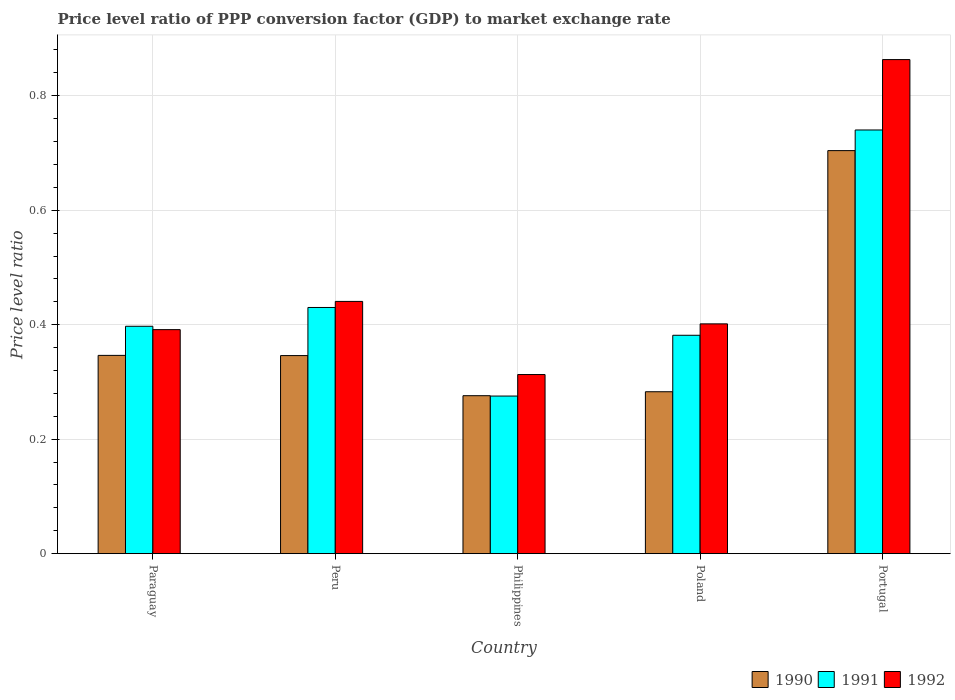How many different coloured bars are there?
Ensure brevity in your answer.  3. How many groups of bars are there?
Provide a succinct answer. 5. How many bars are there on the 2nd tick from the right?
Your response must be concise. 3. What is the label of the 1st group of bars from the left?
Ensure brevity in your answer.  Paraguay. What is the price level ratio in 1990 in Poland?
Your answer should be very brief. 0.28. Across all countries, what is the maximum price level ratio in 1992?
Provide a succinct answer. 0.86. Across all countries, what is the minimum price level ratio in 1991?
Provide a short and direct response. 0.28. In which country was the price level ratio in 1991 minimum?
Offer a very short reply. Philippines. What is the total price level ratio in 1992 in the graph?
Offer a very short reply. 2.41. What is the difference between the price level ratio in 1992 in Paraguay and that in Peru?
Your answer should be very brief. -0.05. What is the difference between the price level ratio in 1992 in Peru and the price level ratio in 1991 in Poland?
Ensure brevity in your answer.  0.06. What is the average price level ratio in 1990 per country?
Give a very brief answer. 0.39. What is the difference between the price level ratio of/in 1992 and price level ratio of/in 1990 in Peru?
Provide a short and direct response. 0.09. In how many countries, is the price level ratio in 1992 greater than 0.6000000000000001?
Ensure brevity in your answer.  1. What is the ratio of the price level ratio in 1992 in Peru to that in Philippines?
Provide a succinct answer. 1.41. Is the difference between the price level ratio in 1992 in Paraguay and Peru greater than the difference between the price level ratio in 1990 in Paraguay and Peru?
Your answer should be very brief. No. What is the difference between the highest and the second highest price level ratio in 1990?
Give a very brief answer. 0.36. What is the difference between the highest and the lowest price level ratio in 1990?
Your answer should be compact. 0.43. In how many countries, is the price level ratio in 1992 greater than the average price level ratio in 1992 taken over all countries?
Provide a short and direct response. 1. What does the 1st bar from the left in Paraguay represents?
Your answer should be compact. 1990. What does the 2nd bar from the right in Portugal represents?
Your response must be concise. 1991. Is it the case that in every country, the sum of the price level ratio in 1991 and price level ratio in 1992 is greater than the price level ratio in 1990?
Your answer should be compact. Yes. Are the values on the major ticks of Y-axis written in scientific E-notation?
Offer a very short reply. No. What is the title of the graph?
Keep it short and to the point. Price level ratio of PPP conversion factor (GDP) to market exchange rate. Does "1965" appear as one of the legend labels in the graph?
Keep it short and to the point. No. What is the label or title of the X-axis?
Your response must be concise. Country. What is the label or title of the Y-axis?
Give a very brief answer. Price level ratio. What is the Price level ratio of 1990 in Paraguay?
Offer a terse response. 0.35. What is the Price level ratio in 1991 in Paraguay?
Your answer should be compact. 0.4. What is the Price level ratio in 1992 in Paraguay?
Give a very brief answer. 0.39. What is the Price level ratio in 1990 in Peru?
Offer a terse response. 0.35. What is the Price level ratio of 1991 in Peru?
Keep it short and to the point. 0.43. What is the Price level ratio in 1992 in Peru?
Offer a terse response. 0.44. What is the Price level ratio of 1990 in Philippines?
Give a very brief answer. 0.28. What is the Price level ratio of 1991 in Philippines?
Your response must be concise. 0.28. What is the Price level ratio of 1992 in Philippines?
Offer a very short reply. 0.31. What is the Price level ratio of 1990 in Poland?
Ensure brevity in your answer.  0.28. What is the Price level ratio in 1991 in Poland?
Ensure brevity in your answer.  0.38. What is the Price level ratio of 1992 in Poland?
Your response must be concise. 0.4. What is the Price level ratio in 1990 in Portugal?
Your answer should be very brief. 0.7. What is the Price level ratio of 1991 in Portugal?
Provide a succinct answer. 0.74. What is the Price level ratio in 1992 in Portugal?
Provide a succinct answer. 0.86. Across all countries, what is the maximum Price level ratio in 1990?
Your response must be concise. 0.7. Across all countries, what is the maximum Price level ratio of 1991?
Ensure brevity in your answer.  0.74. Across all countries, what is the maximum Price level ratio in 1992?
Offer a terse response. 0.86. Across all countries, what is the minimum Price level ratio in 1990?
Make the answer very short. 0.28. Across all countries, what is the minimum Price level ratio of 1991?
Keep it short and to the point. 0.28. Across all countries, what is the minimum Price level ratio in 1992?
Provide a succinct answer. 0.31. What is the total Price level ratio in 1990 in the graph?
Give a very brief answer. 1.96. What is the total Price level ratio of 1991 in the graph?
Keep it short and to the point. 2.22. What is the total Price level ratio in 1992 in the graph?
Provide a succinct answer. 2.41. What is the difference between the Price level ratio in 1990 in Paraguay and that in Peru?
Provide a short and direct response. 0. What is the difference between the Price level ratio of 1991 in Paraguay and that in Peru?
Provide a short and direct response. -0.03. What is the difference between the Price level ratio in 1992 in Paraguay and that in Peru?
Your answer should be compact. -0.05. What is the difference between the Price level ratio in 1990 in Paraguay and that in Philippines?
Your answer should be very brief. 0.07. What is the difference between the Price level ratio of 1991 in Paraguay and that in Philippines?
Offer a very short reply. 0.12. What is the difference between the Price level ratio of 1992 in Paraguay and that in Philippines?
Give a very brief answer. 0.08. What is the difference between the Price level ratio in 1990 in Paraguay and that in Poland?
Provide a short and direct response. 0.06. What is the difference between the Price level ratio of 1991 in Paraguay and that in Poland?
Offer a very short reply. 0.02. What is the difference between the Price level ratio of 1992 in Paraguay and that in Poland?
Your answer should be very brief. -0.01. What is the difference between the Price level ratio in 1990 in Paraguay and that in Portugal?
Ensure brevity in your answer.  -0.36. What is the difference between the Price level ratio of 1991 in Paraguay and that in Portugal?
Keep it short and to the point. -0.34. What is the difference between the Price level ratio of 1992 in Paraguay and that in Portugal?
Provide a succinct answer. -0.47. What is the difference between the Price level ratio in 1990 in Peru and that in Philippines?
Provide a short and direct response. 0.07. What is the difference between the Price level ratio in 1991 in Peru and that in Philippines?
Ensure brevity in your answer.  0.15. What is the difference between the Price level ratio in 1992 in Peru and that in Philippines?
Ensure brevity in your answer.  0.13. What is the difference between the Price level ratio of 1990 in Peru and that in Poland?
Your response must be concise. 0.06. What is the difference between the Price level ratio in 1991 in Peru and that in Poland?
Keep it short and to the point. 0.05. What is the difference between the Price level ratio of 1992 in Peru and that in Poland?
Give a very brief answer. 0.04. What is the difference between the Price level ratio of 1990 in Peru and that in Portugal?
Ensure brevity in your answer.  -0.36. What is the difference between the Price level ratio in 1991 in Peru and that in Portugal?
Keep it short and to the point. -0.31. What is the difference between the Price level ratio in 1992 in Peru and that in Portugal?
Your answer should be very brief. -0.42. What is the difference between the Price level ratio in 1990 in Philippines and that in Poland?
Provide a short and direct response. -0.01. What is the difference between the Price level ratio of 1991 in Philippines and that in Poland?
Provide a short and direct response. -0.11. What is the difference between the Price level ratio in 1992 in Philippines and that in Poland?
Ensure brevity in your answer.  -0.09. What is the difference between the Price level ratio of 1990 in Philippines and that in Portugal?
Keep it short and to the point. -0.43. What is the difference between the Price level ratio in 1991 in Philippines and that in Portugal?
Provide a succinct answer. -0.46. What is the difference between the Price level ratio of 1992 in Philippines and that in Portugal?
Provide a succinct answer. -0.55. What is the difference between the Price level ratio in 1990 in Poland and that in Portugal?
Your answer should be very brief. -0.42. What is the difference between the Price level ratio in 1991 in Poland and that in Portugal?
Offer a terse response. -0.36. What is the difference between the Price level ratio of 1992 in Poland and that in Portugal?
Your answer should be very brief. -0.46. What is the difference between the Price level ratio in 1990 in Paraguay and the Price level ratio in 1991 in Peru?
Provide a succinct answer. -0.08. What is the difference between the Price level ratio in 1990 in Paraguay and the Price level ratio in 1992 in Peru?
Give a very brief answer. -0.09. What is the difference between the Price level ratio of 1991 in Paraguay and the Price level ratio of 1992 in Peru?
Make the answer very short. -0.04. What is the difference between the Price level ratio in 1990 in Paraguay and the Price level ratio in 1991 in Philippines?
Provide a succinct answer. 0.07. What is the difference between the Price level ratio in 1990 in Paraguay and the Price level ratio in 1992 in Philippines?
Give a very brief answer. 0.03. What is the difference between the Price level ratio of 1991 in Paraguay and the Price level ratio of 1992 in Philippines?
Offer a terse response. 0.08. What is the difference between the Price level ratio of 1990 in Paraguay and the Price level ratio of 1991 in Poland?
Keep it short and to the point. -0.04. What is the difference between the Price level ratio of 1990 in Paraguay and the Price level ratio of 1992 in Poland?
Give a very brief answer. -0.06. What is the difference between the Price level ratio of 1991 in Paraguay and the Price level ratio of 1992 in Poland?
Provide a succinct answer. -0. What is the difference between the Price level ratio in 1990 in Paraguay and the Price level ratio in 1991 in Portugal?
Your answer should be compact. -0.39. What is the difference between the Price level ratio of 1990 in Paraguay and the Price level ratio of 1992 in Portugal?
Ensure brevity in your answer.  -0.52. What is the difference between the Price level ratio of 1991 in Paraguay and the Price level ratio of 1992 in Portugal?
Your response must be concise. -0.47. What is the difference between the Price level ratio in 1990 in Peru and the Price level ratio in 1991 in Philippines?
Offer a very short reply. 0.07. What is the difference between the Price level ratio of 1990 in Peru and the Price level ratio of 1992 in Philippines?
Offer a very short reply. 0.03. What is the difference between the Price level ratio in 1991 in Peru and the Price level ratio in 1992 in Philippines?
Give a very brief answer. 0.12. What is the difference between the Price level ratio in 1990 in Peru and the Price level ratio in 1991 in Poland?
Your response must be concise. -0.04. What is the difference between the Price level ratio in 1990 in Peru and the Price level ratio in 1992 in Poland?
Provide a succinct answer. -0.06. What is the difference between the Price level ratio of 1991 in Peru and the Price level ratio of 1992 in Poland?
Your response must be concise. 0.03. What is the difference between the Price level ratio of 1990 in Peru and the Price level ratio of 1991 in Portugal?
Make the answer very short. -0.39. What is the difference between the Price level ratio of 1990 in Peru and the Price level ratio of 1992 in Portugal?
Your answer should be very brief. -0.52. What is the difference between the Price level ratio of 1991 in Peru and the Price level ratio of 1992 in Portugal?
Keep it short and to the point. -0.43. What is the difference between the Price level ratio of 1990 in Philippines and the Price level ratio of 1991 in Poland?
Offer a terse response. -0.11. What is the difference between the Price level ratio of 1990 in Philippines and the Price level ratio of 1992 in Poland?
Keep it short and to the point. -0.13. What is the difference between the Price level ratio of 1991 in Philippines and the Price level ratio of 1992 in Poland?
Your answer should be very brief. -0.13. What is the difference between the Price level ratio in 1990 in Philippines and the Price level ratio in 1991 in Portugal?
Provide a short and direct response. -0.46. What is the difference between the Price level ratio in 1990 in Philippines and the Price level ratio in 1992 in Portugal?
Provide a succinct answer. -0.59. What is the difference between the Price level ratio in 1991 in Philippines and the Price level ratio in 1992 in Portugal?
Your answer should be compact. -0.59. What is the difference between the Price level ratio of 1990 in Poland and the Price level ratio of 1991 in Portugal?
Your answer should be compact. -0.46. What is the difference between the Price level ratio in 1990 in Poland and the Price level ratio in 1992 in Portugal?
Keep it short and to the point. -0.58. What is the difference between the Price level ratio of 1991 in Poland and the Price level ratio of 1992 in Portugal?
Keep it short and to the point. -0.48. What is the average Price level ratio in 1990 per country?
Give a very brief answer. 0.39. What is the average Price level ratio of 1991 per country?
Your answer should be compact. 0.44. What is the average Price level ratio in 1992 per country?
Provide a succinct answer. 0.48. What is the difference between the Price level ratio in 1990 and Price level ratio in 1991 in Paraguay?
Ensure brevity in your answer.  -0.05. What is the difference between the Price level ratio of 1990 and Price level ratio of 1992 in Paraguay?
Your answer should be very brief. -0.04. What is the difference between the Price level ratio of 1991 and Price level ratio of 1992 in Paraguay?
Keep it short and to the point. 0.01. What is the difference between the Price level ratio in 1990 and Price level ratio in 1991 in Peru?
Make the answer very short. -0.08. What is the difference between the Price level ratio in 1990 and Price level ratio in 1992 in Peru?
Make the answer very short. -0.09. What is the difference between the Price level ratio in 1991 and Price level ratio in 1992 in Peru?
Offer a very short reply. -0.01. What is the difference between the Price level ratio of 1990 and Price level ratio of 1991 in Philippines?
Provide a short and direct response. 0. What is the difference between the Price level ratio in 1990 and Price level ratio in 1992 in Philippines?
Provide a short and direct response. -0.04. What is the difference between the Price level ratio of 1991 and Price level ratio of 1992 in Philippines?
Keep it short and to the point. -0.04. What is the difference between the Price level ratio in 1990 and Price level ratio in 1991 in Poland?
Your response must be concise. -0.1. What is the difference between the Price level ratio in 1990 and Price level ratio in 1992 in Poland?
Ensure brevity in your answer.  -0.12. What is the difference between the Price level ratio in 1991 and Price level ratio in 1992 in Poland?
Provide a short and direct response. -0.02. What is the difference between the Price level ratio in 1990 and Price level ratio in 1991 in Portugal?
Your response must be concise. -0.04. What is the difference between the Price level ratio in 1990 and Price level ratio in 1992 in Portugal?
Your answer should be compact. -0.16. What is the difference between the Price level ratio of 1991 and Price level ratio of 1992 in Portugal?
Ensure brevity in your answer.  -0.12. What is the ratio of the Price level ratio of 1990 in Paraguay to that in Peru?
Your answer should be very brief. 1. What is the ratio of the Price level ratio of 1991 in Paraguay to that in Peru?
Your response must be concise. 0.92. What is the ratio of the Price level ratio in 1992 in Paraguay to that in Peru?
Your answer should be very brief. 0.89. What is the ratio of the Price level ratio of 1990 in Paraguay to that in Philippines?
Your response must be concise. 1.26. What is the ratio of the Price level ratio in 1991 in Paraguay to that in Philippines?
Offer a terse response. 1.44. What is the ratio of the Price level ratio in 1992 in Paraguay to that in Philippines?
Make the answer very short. 1.25. What is the ratio of the Price level ratio of 1990 in Paraguay to that in Poland?
Give a very brief answer. 1.22. What is the ratio of the Price level ratio in 1991 in Paraguay to that in Poland?
Make the answer very short. 1.04. What is the ratio of the Price level ratio of 1992 in Paraguay to that in Poland?
Offer a very short reply. 0.97. What is the ratio of the Price level ratio of 1990 in Paraguay to that in Portugal?
Ensure brevity in your answer.  0.49. What is the ratio of the Price level ratio in 1991 in Paraguay to that in Portugal?
Give a very brief answer. 0.54. What is the ratio of the Price level ratio of 1992 in Paraguay to that in Portugal?
Make the answer very short. 0.45. What is the ratio of the Price level ratio of 1990 in Peru to that in Philippines?
Ensure brevity in your answer.  1.25. What is the ratio of the Price level ratio in 1991 in Peru to that in Philippines?
Offer a very short reply. 1.56. What is the ratio of the Price level ratio of 1992 in Peru to that in Philippines?
Offer a very short reply. 1.41. What is the ratio of the Price level ratio in 1990 in Peru to that in Poland?
Make the answer very short. 1.22. What is the ratio of the Price level ratio in 1991 in Peru to that in Poland?
Offer a terse response. 1.13. What is the ratio of the Price level ratio in 1992 in Peru to that in Poland?
Give a very brief answer. 1.1. What is the ratio of the Price level ratio of 1990 in Peru to that in Portugal?
Offer a terse response. 0.49. What is the ratio of the Price level ratio of 1991 in Peru to that in Portugal?
Your answer should be very brief. 0.58. What is the ratio of the Price level ratio in 1992 in Peru to that in Portugal?
Ensure brevity in your answer.  0.51. What is the ratio of the Price level ratio of 1990 in Philippines to that in Poland?
Provide a short and direct response. 0.98. What is the ratio of the Price level ratio of 1991 in Philippines to that in Poland?
Offer a very short reply. 0.72. What is the ratio of the Price level ratio in 1992 in Philippines to that in Poland?
Offer a very short reply. 0.78. What is the ratio of the Price level ratio of 1990 in Philippines to that in Portugal?
Offer a very short reply. 0.39. What is the ratio of the Price level ratio in 1991 in Philippines to that in Portugal?
Ensure brevity in your answer.  0.37. What is the ratio of the Price level ratio of 1992 in Philippines to that in Portugal?
Your answer should be compact. 0.36. What is the ratio of the Price level ratio in 1990 in Poland to that in Portugal?
Ensure brevity in your answer.  0.4. What is the ratio of the Price level ratio of 1991 in Poland to that in Portugal?
Your response must be concise. 0.52. What is the ratio of the Price level ratio of 1992 in Poland to that in Portugal?
Give a very brief answer. 0.47. What is the difference between the highest and the second highest Price level ratio in 1990?
Offer a terse response. 0.36. What is the difference between the highest and the second highest Price level ratio in 1991?
Your answer should be compact. 0.31. What is the difference between the highest and the second highest Price level ratio in 1992?
Keep it short and to the point. 0.42. What is the difference between the highest and the lowest Price level ratio of 1990?
Your response must be concise. 0.43. What is the difference between the highest and the lowest Price level ratio in 1991?
Provide a short and direct response. 0.46. What is the difference between the highest and the lowest Price level ratio of 1992?
Keep it short and to the point. 0.55. 